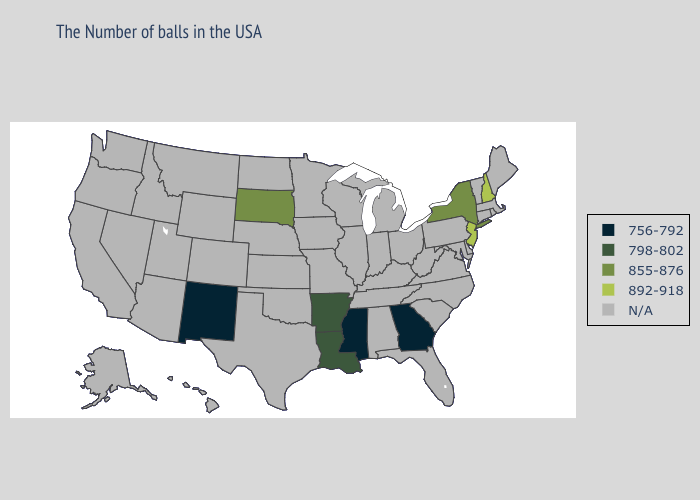What is the highest value in the USA?
Quick response, please. 892-918. Name the states that have a value in the range 892-918?
Short answer required. New Hampshire, New Jersey. What is the lowest value in the USA?
Quick response, please. 756-792. Name the states that have a value in the range N/A?
Concise answer only. Maine, Massachusetts, Rhode Island, Vermont, Connecticut, Delaware, Maryland, Pennsylvania, Virginia, North Carolina, South Carolina, West Virginia, Ohio, Florida, Michigan, Kentucky, Indiana, Alabama, Tennessee, Wisconsin, Illinois, Missouri, Minnesota, Iowa, Kansas, Nebraska, Oklahoma, Texas, North Dakota, Wyoming, Colorado, Utah, Montana, Arizona, Idaho, Nevada, California, Washington, Oregon, Alaska, Hawaii. Does Georgia have the highest value in the USA?
Concise answer only. No. What is the highest value in the Northeast ?
Write a very short answer. 892-918. Does the first symbol in the legend represent the smallest category?
Keep it brief. Yes. Does Mississippi have the lowest value in the USA?
Write a very short answer. Yes. What is the lowest value in the USA?
Quick response, please. 756-792. What is the value of Hawaii?
Write a very short answer. N/A. Does the first symbol in the legend represent the smallest category?
Concise answer only. Yes. What is the value of Arkansas?
Quick response, please. 798-802. 